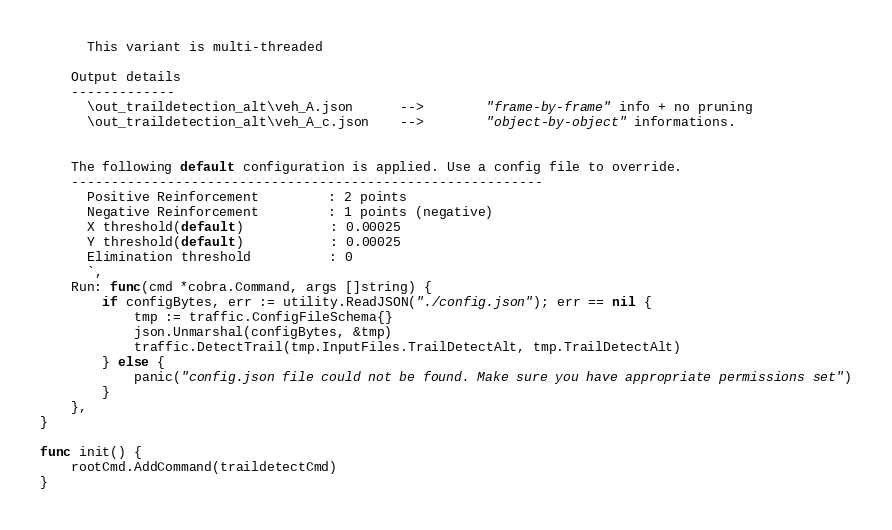<code> <loc_0><loc_0><loc_500><loc_500><_Go_>      This variant is multi-threaded

	Output details
	-------------
	  \out_traildetection_alt\veh_A.json      -->		"frame-by-frame" info + no pruning
	  \out_traildetection_alt\veh_A_c.json    -->		"object-by-object" informations.
  
  
	The following default configuration is applied. Use a config file to override.
	-----------------------------------------------------------
	  Positive Reinforcement         : 2 points
	  Negative Reinforcement         : 1 points (negative)
	  X threshold(default)           : 0.00025
	  Y threshold(default)           : 0.00025
	  Elimination threshold          : 0
	  `,
	Run: func(cmd *cobra.Command, args []string) {
		if configBytes, err := utility.ReadJSON("./config.json"); err == nil {
			tmp := traffic.ConfigFileSchema{}
			json.Unmarshal(configBytes, &tmp)
			traffic.DetectTrail(tmp.InputFiles.TrailDetectAlt, tmp.TrailDetectAlt)
		} else {
			panic("config.json file could not be found. Make sure you have appropriate permissions set")
		}
	},
}

func init() {
	rootCmd.AddCommand(traildetectCmd)
}
</code> 